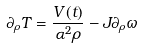<formula> <loc_0><loc_0><loc_500><loc_500>\partial _ { \rho } T = \frac { V ( t ) } { \alpha ^ { 2 } \rho } - J \partial _ { \rho } \omega</formula> 